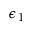<formula> <loc_0><loc_0><loc_500><loc_500>\epsilon _ { 1 }</formula> 